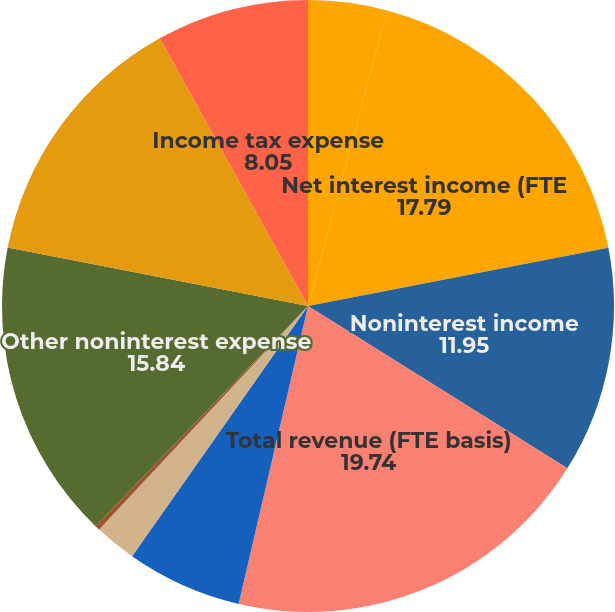<chart> <loc_0><loc_0><loc_500><loc_500><pie_chart><fcel>(Dollars in millions)<fcel>Net interest income (FTE<fcel>Noninterest income<fcel>Total revenue (FTE basis)<fcel>Provision for credit losses<fcel>Gains (losses) on sales of<fcel>Amortization of intangibles<fcel>Other noninterest expense<fcel>Income before income taxes<fcel>Income tax expense<nl><fcel>4.16%<fcel>17.79%<fcel>11.95%<fcel>19.74%<fcel>6.11%<fcel>2.21%<fcel>0.26%<fcel>15.84%<fcel>13.89%<fcel>8.05%<nl></chart> 